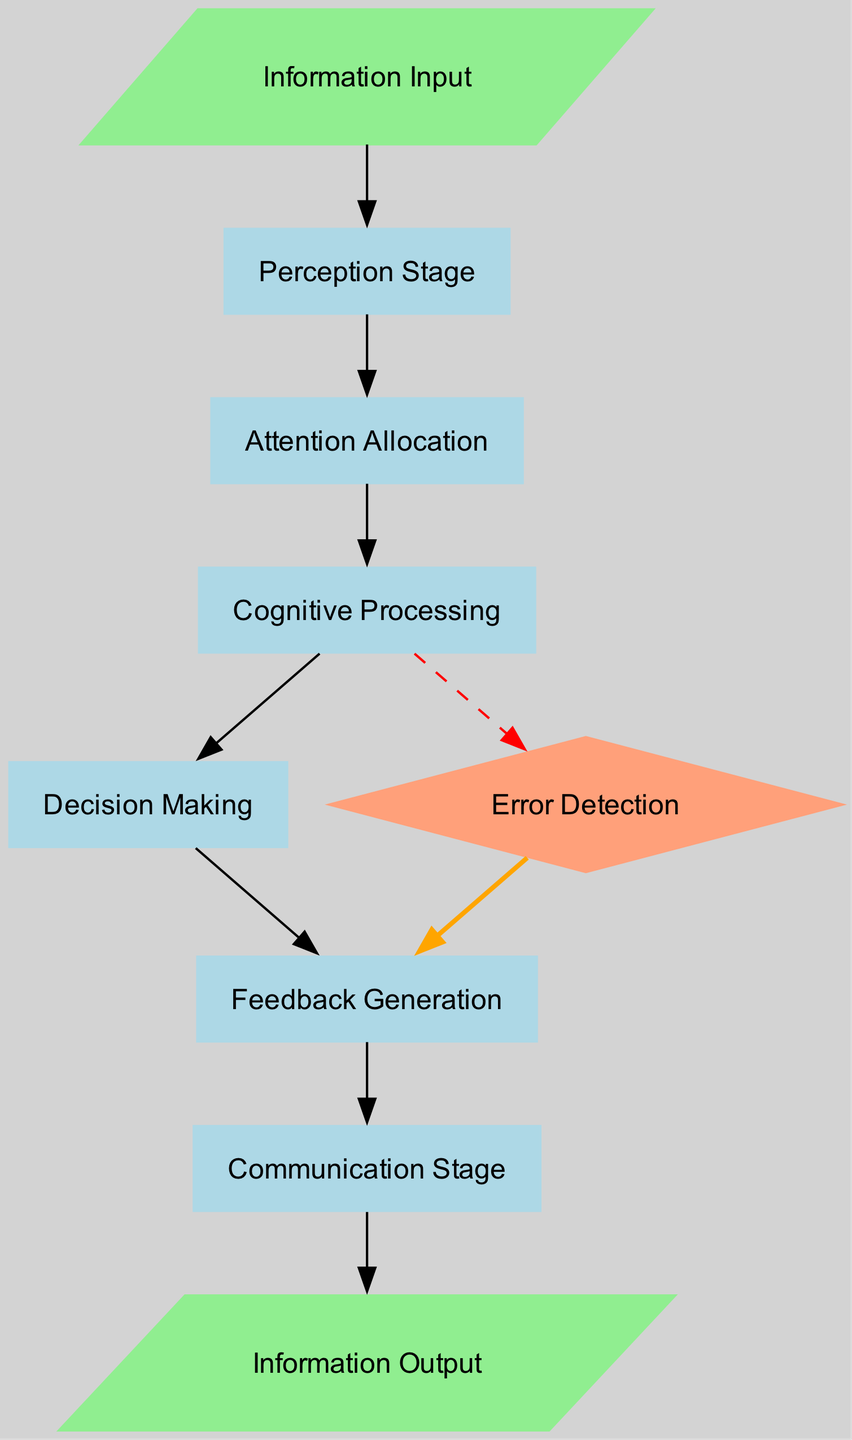1. What is the first stage of information processing? The first node in the diagram indicates the initial stage where information is received, which is labeled "Information Input."
Answer: Information Input 2. How many nodes are in the diagram? By counting each distinct node listed, there are a total of 9 nodes present in the diagram.
Answer: 9 3. Which node comes after "Cognition"? Following the directed edge from "Cognition," the next node in the sequence is "Decision Making."
Answer: Decision Making 4. What is the shape of the "Error Detection" node? The diagram uses a diamond shape specifically for the "Error Detection" node, which signifies a decision point regarding potential errors.
Answer: diamond 5. Identify the relationship between "Decision Making" and "Feedback Generation." The diagram shows a direct path from "Decision Making" leading to "Feedback Generation," indicating that feedback is produced after making a decision.
Answer: direct path 6. What color represents the edges leading to the "Error Detection" node? In the diagram, the edges that point to "Error Detection" are colored red and marked with a dashed style, indicating a specific type of flow related to potential errors.
Answer: red 7. How many edges are there connecting "Cognition" to other nodes? From examining the diagram's connections, "Cognition" has two outgoing edges: one leading to "Decision Making" and another to "Error Detection."
Answer: 2 8. What occurs after "Feedback Generation"? The next node after "Feedback Generation," according to the diagram, is "Communication Stage," suggesting that feedback is communicated once generated.
Answer: Communication Stage 9. Which node produces an output in the diagram? The final stage in the information flow is represented by the node labeled "Information Output," indicating the point where processed information is released.
Answer: Information Output 